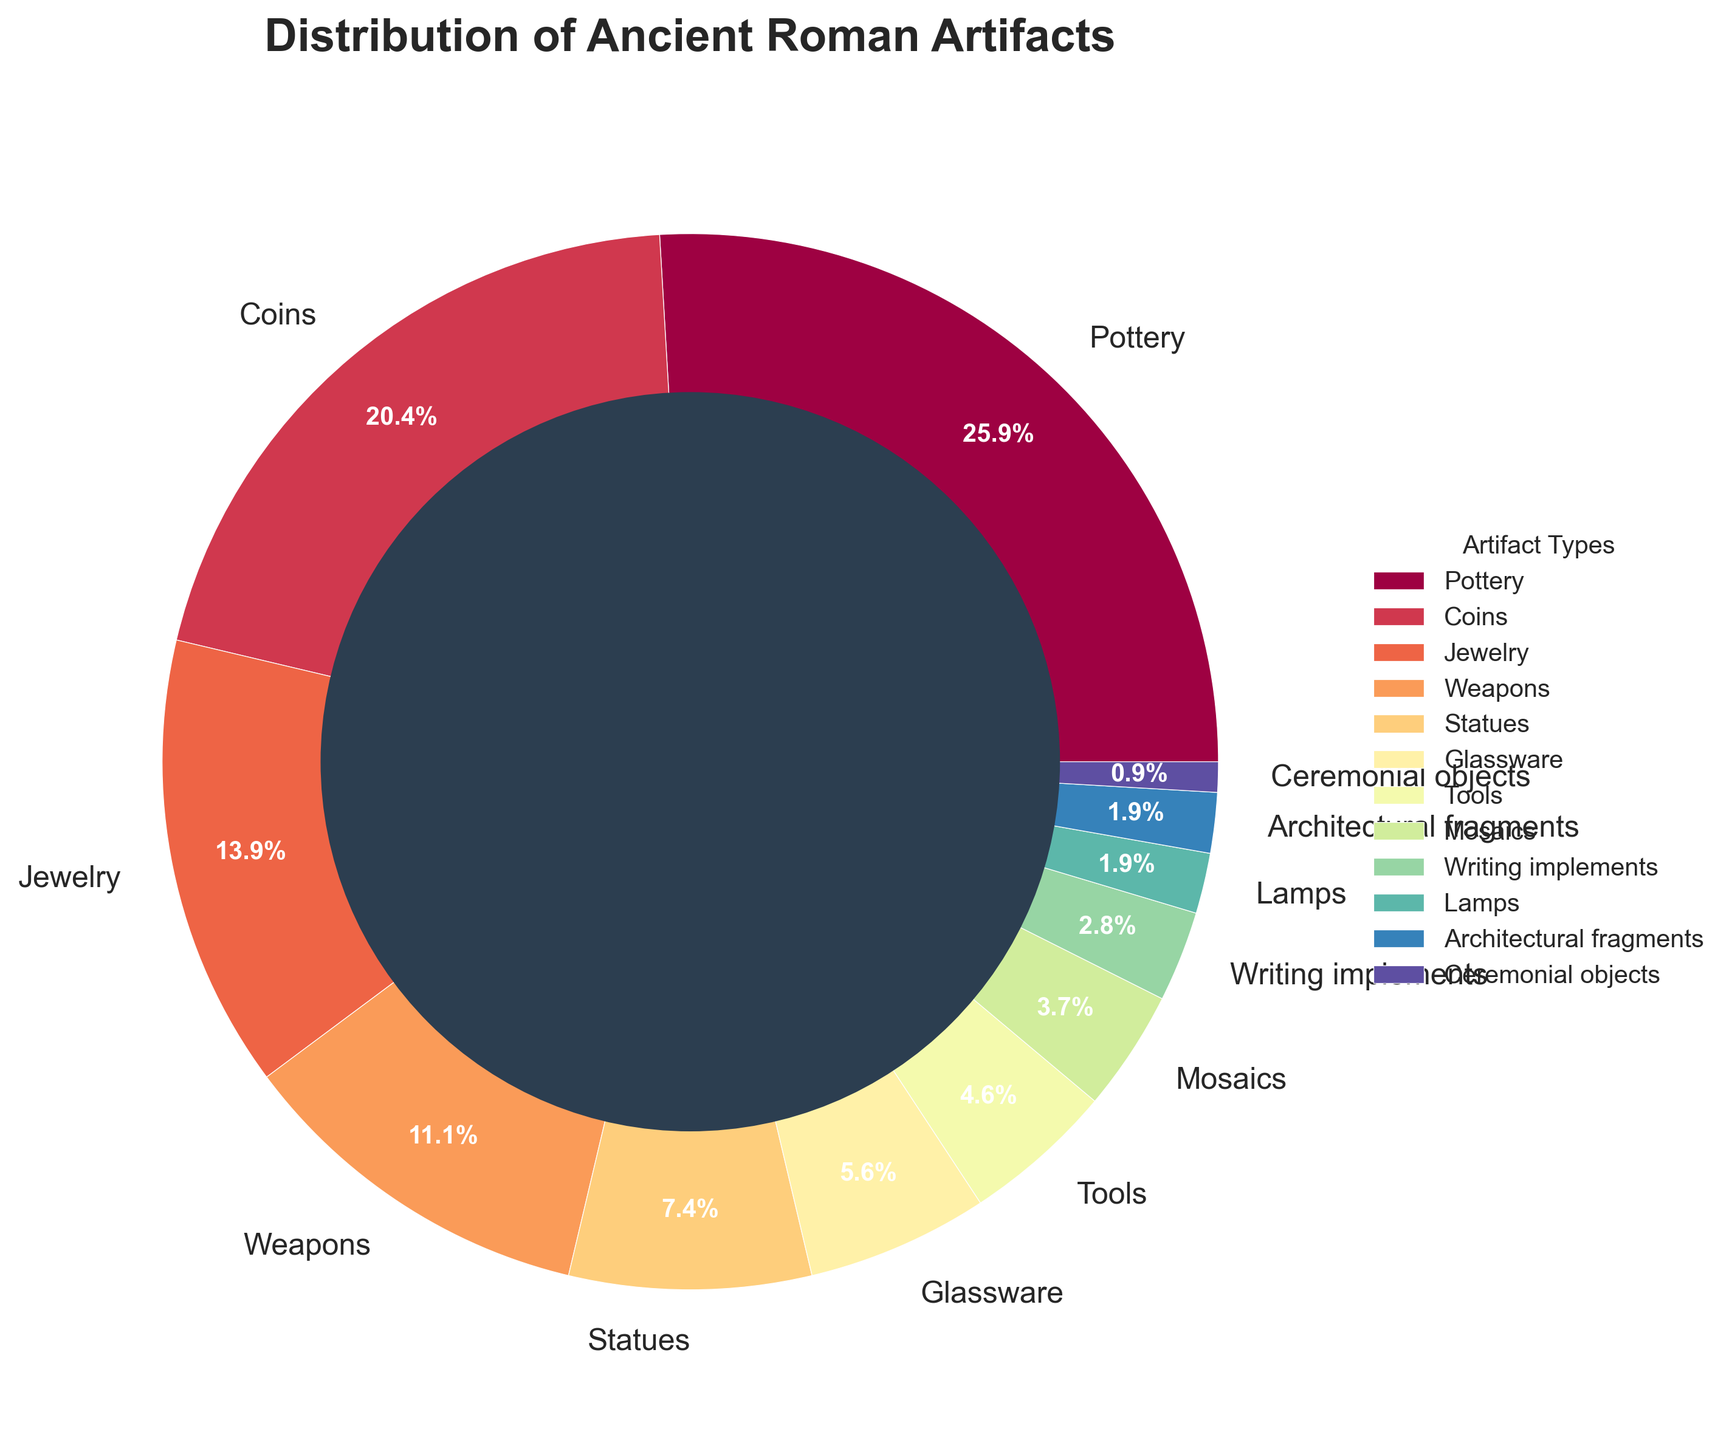What is the most common type of artifact found in ancient Roman excavations? The pie chart shows different artifact types with their corresponding percentages. The artifact with the highest percentage is "Pottery" at 28%.
Answer: Pottery Which type of artifact is less common: Jewelry or Weapons? Observe the percentages of Jewelry (15%) and Weapons (12%) in the chart. Compare these values. Jewelry is more common than Weapons.
Answer: Weapons What is the combined percentage of Mosaics and Writing implements? Identify the individual percentages for Mosaics (4%) and Writing implements (3%). Add these values: 4% + 3% = 7%.
Answer: 7% Which artifact type has a smaller percentage: Glassware or Statues? Compare the percentages of Glassware (6%) and Statues (8%). Glassware has a smaller percentage than Statues.
Answer: Glassware How does the sum of the percentages of Coins and Jewelry compare to the percentage of Pottery? Find the percentages of Coins (22%) and Jewelry (15%). Their sum is 22% + 15% = 37%, which is greater than the percentage of Pottery (28%).
Answer: Greater Which artifact is represented by a visually smaller segment of the pie chart, Lamps or Tools? Observe the pie chart and find the size of each segment. Lamps are 2% and Tools are 5%. Lamps represent a visually smaller segment.
Answer: Lamps What is the difference in percentage between Tools and Architectural fragments? Identify the percentages for Tools (5%) and Architectural fragments (2%). Subtract the smaller percentage from the larger one: 5% - 2% = 3%.
Answer: 3% Determine the types of artifacts that have percentages smaller than 5%. Identify which artifact types in the pie chart have percentages below 5%. These are Writing implements (3%), Lamps (2%), Architectural fragments (2%), and Ceremonial objects (1%).
Answer: Writing implements, Lamps, Architectural fragments, Ceremonial objects What fraction of the total artifacts do Ceremonial objects and Lamps represent together? Identify the percentages for Ceremonial objects (1%) and Lamps (2%). Their sum is 1% + 2% = 3%. This represents 3/100 or 3% of the total.
Answer: 3% Which artifact type is represented by the darkest segment in the pie chart? Observe the color gradient in the pie chart and determine the darkest segment. Typically, the segment with the highest percentage also has a distinct, prominent color. Pottery, being the largest segment at 28%, is likely the darkest.
Answer: Pottery 